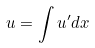Convert formula to latex. <formula><loc_0><loc_0><loc_500><loc_500>u = \int u ^ { \prime } d x</formula> 